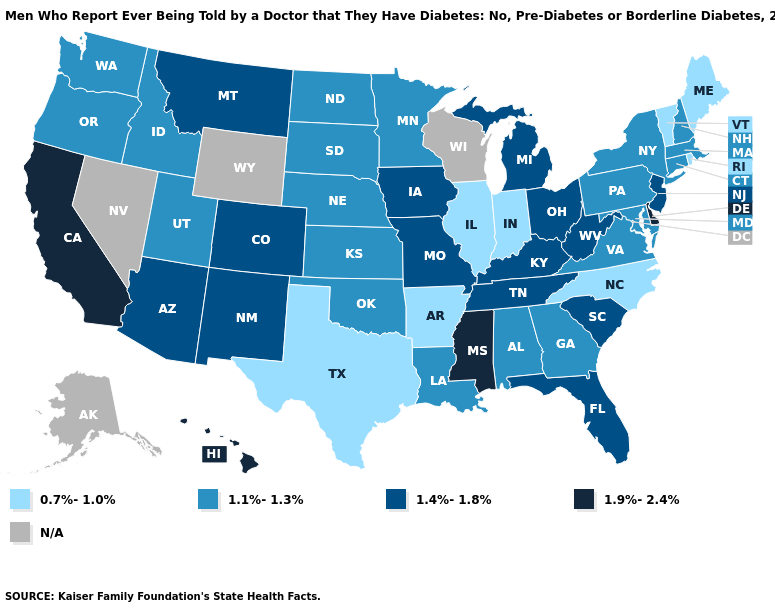Which states have the highest value in the USA?
Give a very brief answer. California, Delaware, Hawaii, Mississippi. What is the highest value in states that border Nebraska?
Concise answer only. 1.4%-1.8%. Which states have the lowest value in the Northeast?
Concise answer only. Maine, Rhode Island, Vermont. What is the value of Delaware?
Concise answer only. 1.9%-2.4%. Does Maine have the lowest value in the USA?
Give a very brief answer. Yes. Which states have the highest value in the USA?
Write a very short answer. California, Delaware, Hawaii, Mississippi. What is the value of Rhode Island?
Short answer required. 0.7%-1.0%. Which states have the lowest value in the West?
Give a very brief answer. Idaho, Oregon, Utah, Washington. What is the value of Oregon?
Be succinct. 1.1%-1.3%. Name the states that have a value in the range 1.1%-1.3%?
Short answer required. Alabama, Connecticut, Georgia, Idaho, Kansas, Louisiana, Maryland, Massachusetts, Minnesota, Nebraska, New Hampshire, New York, North Dakota, Oklahoma, Oregon, Pennsylvania, South Dakota, Utah, Virginia, Washington. Which states have the lowest value in the MidWest?
Keep it brief. Illinois, Indiana. Is the legend a continuous bar?
Give a very brief answer. No. Which states hav the highest value in the Northeast?
Write a very short answer. New Jersey. Which states have the highest value in the USA?
Short answer required. California, Delaware, Hawaii, Mississippi. 